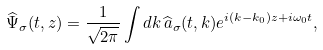<formula> <loc_0><loc_0><loc_500><loc_500>\widehat { \Psi } _ { \sigma } ( t , z ) = \frac { 1 } { \sqrt { 2 \pi } } \int d k \, \widehat { a } _ { \sigma } ( t , k ) e ^ { i ( k - k _ { 0 } ) z + i \omega _ { 0 } t } ,</formula> 